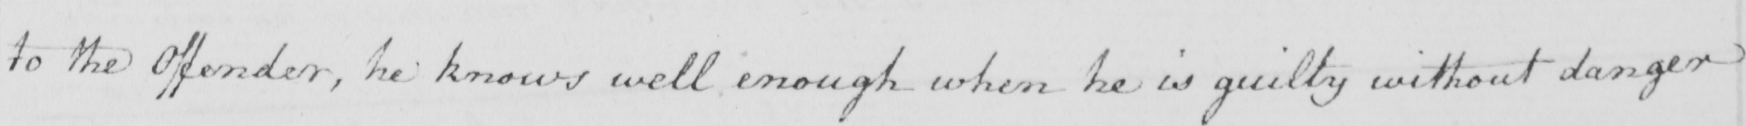Please provide the text content of this handwritten line. to the offender , he knows well enough when he is guilty without danger 